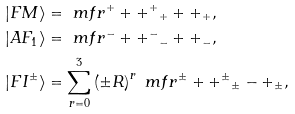Convert formula to latex. <formula><loc_0><loc_0><loc_500><loc_500>| F M \rangle & = \ m f r { ^ { + } + + ^ { + } } { _ { + } + + _ { + } } , \\ | A F _ { 1 } \rangle & = \ m f r { ^ { - } + + ^ { - } } { _ { - } + + _ { - } } , \\ | F I ^ { \pm } \rangle & = \sum _ { r = 0 } ^ { 3 } \left ( \pm R \right ) ^ { r } \ m f r { ^ { \pm } + + ^ { \pm } } { _ { \pm } - + _ { \pm } } ,</formula> 